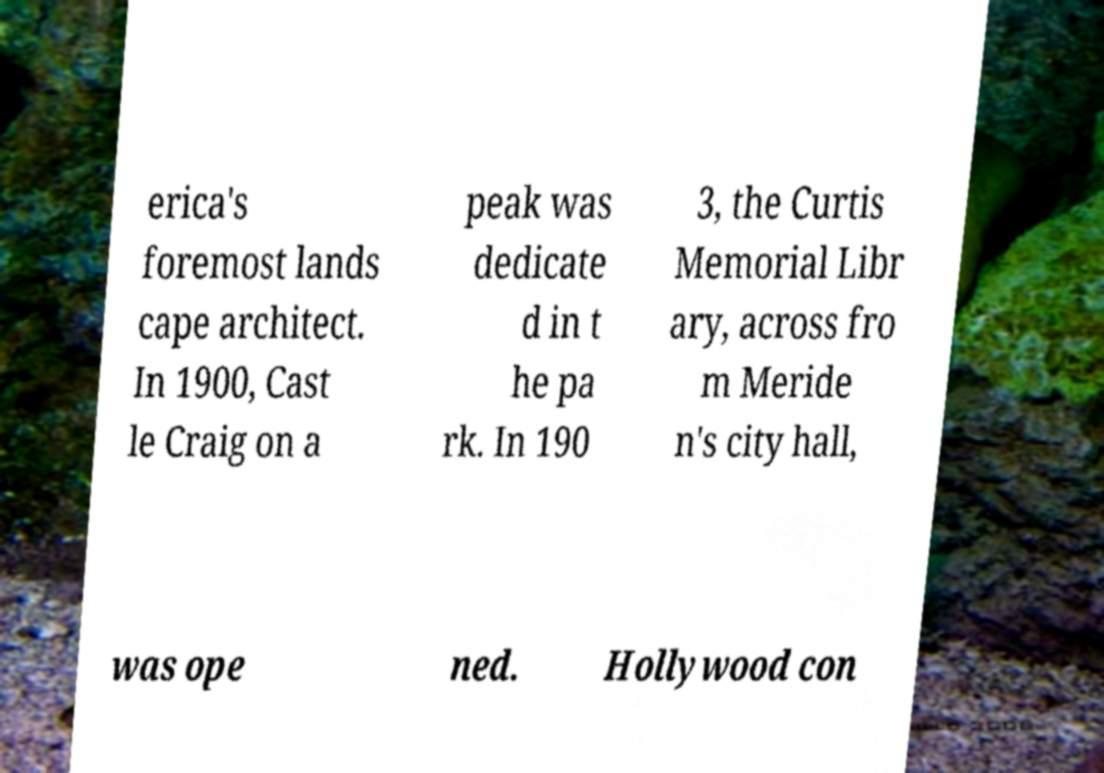Could you extract and type out the text from this image? erica's foremost lands cape architect. In 1900, Cast le Craig on a peak was dedicate d in t he pa rk. In 190 3, the Curtis Memorial Libr ary, across fro m Meride n's city hall, was ope ned. Hollywood con 